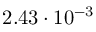<formula> <loc_0><loc_0><loc_500><loc_500>2 . 4 3 \cdot 1 0 ^ { - 3 }</formula> 